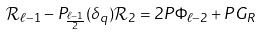<formula> <loc_0><loc_0><loc_500><loc_500>\mathcal { R } _ { \ell - 1 } - P _ { \frac { \ell - 1 } { 2 } } ( \delta _ { q } ) \mathcal { R } _ { 2 } = 2 P \Phi _ { \ell - 2 } + P G _ { R }</formula> 